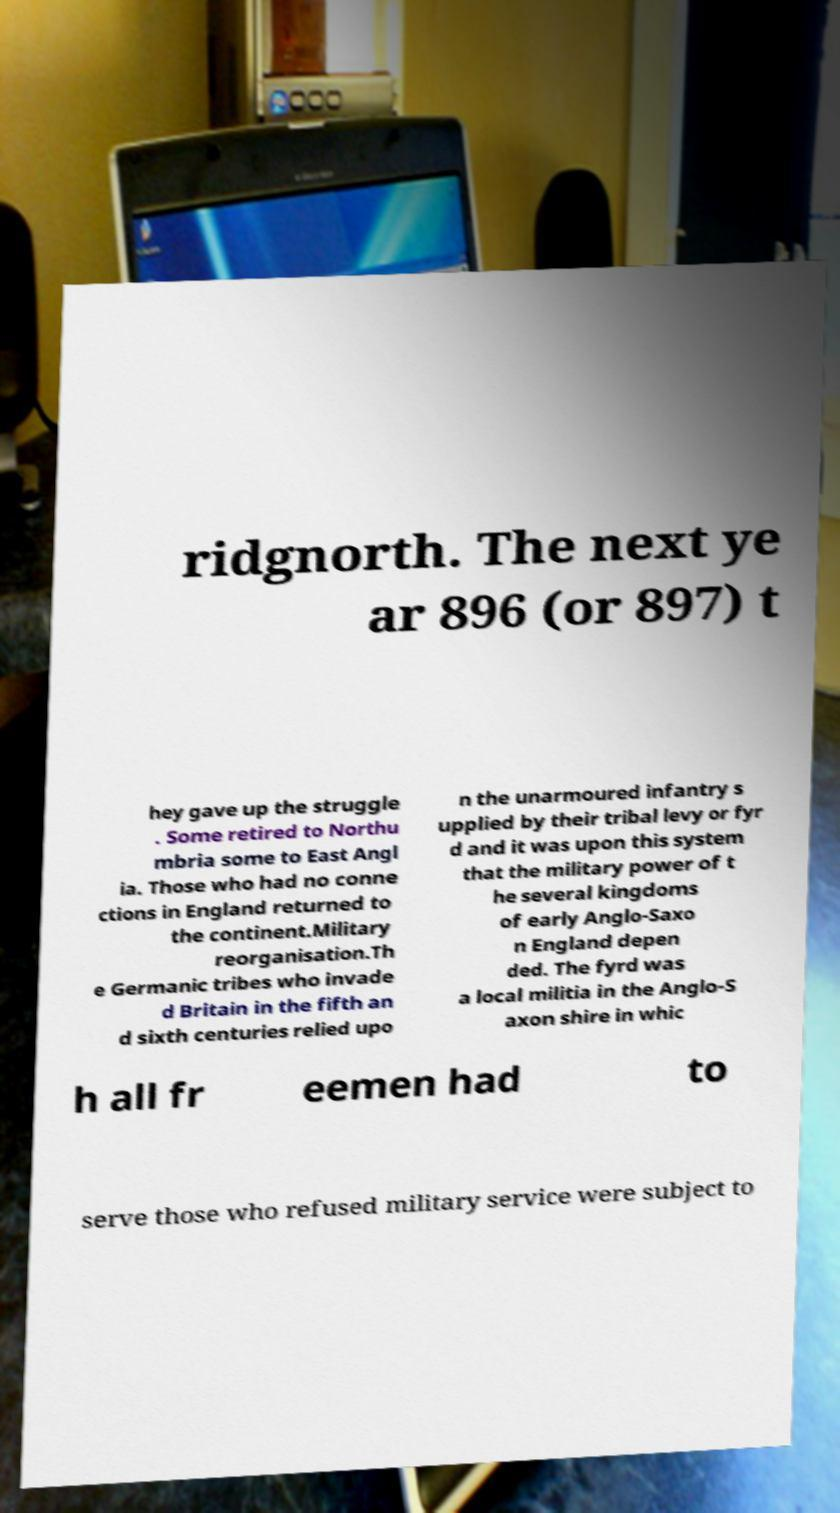Please read and relay the text visible in this image. What does it say? ridgnorth. The next ye ar 896 (or 897) t hey gave up the struggle . Some retired to Northu mbria some to East Angl ia. Those who had no conne ctions in England returned to the continent.Military reorganisation.Th e Germanic tribes who invade d Britain in the fifth an d sixth centuries relied upo n the unarmoured infantry s upplied by their tribal levy or fyr d and it was upon this system that the military power of t he several kingdoms of early Anglo-Saxo n England depen ded. The fyrd was a local militia in the Anglo-S axon shire in whic h all fr eemen had to serve those who refused military service were subject to 